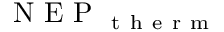Convert formula to latex. <formula><loc_0><loc_0><loc_500><loc_500>N E P _ { t h e r m }</formula> 